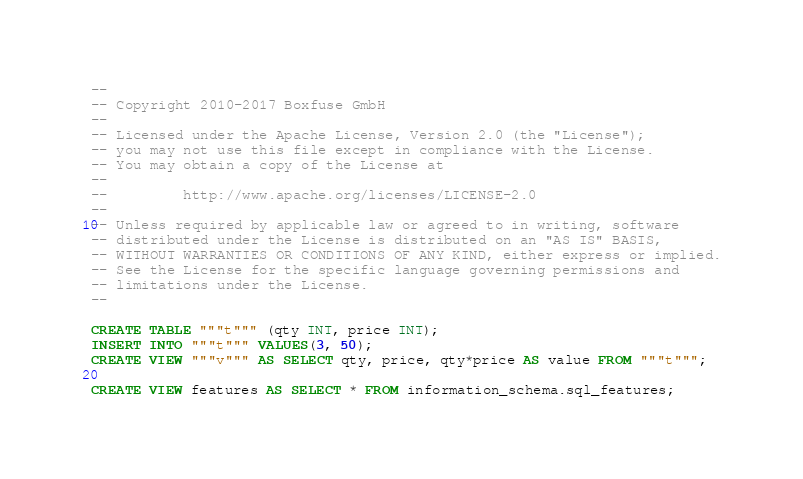<code> <loc_0><loc_0><loc_500><loc_500><_SQL_>--
-- Copyright 2010-2017 Boxfuse GmbH
--
-- Licensed under the Apache License, Version 2.0 (the "License");
-- you may not use this file except in compliance with the License.
-- You may obtain a copy of the License at
--
--         http://www.apache.org/licenses/LICENSE-2.0
--
-- Unless required by applicable law or agreed to in writing, software
-- distributed under the License is distributed on an "AS IS" BASIS,
-- WITHOUT WARRANTIES OR CONDITIONS OF ANY KIND, either express or implied.
-- See the License for the specific language governing permissions and
-- limitations under the License.
--

CREATE TABLE """t""" (qty INT, price INT);
INSERT INTO """t""" VALUES(3, 50);
CREATE VIEW """v""" AS SELECT qty, price, qty*price AS value FROM """t""";

CREATE VIEW features AS SELECT * FROM information_schema.sql_features;</code> 